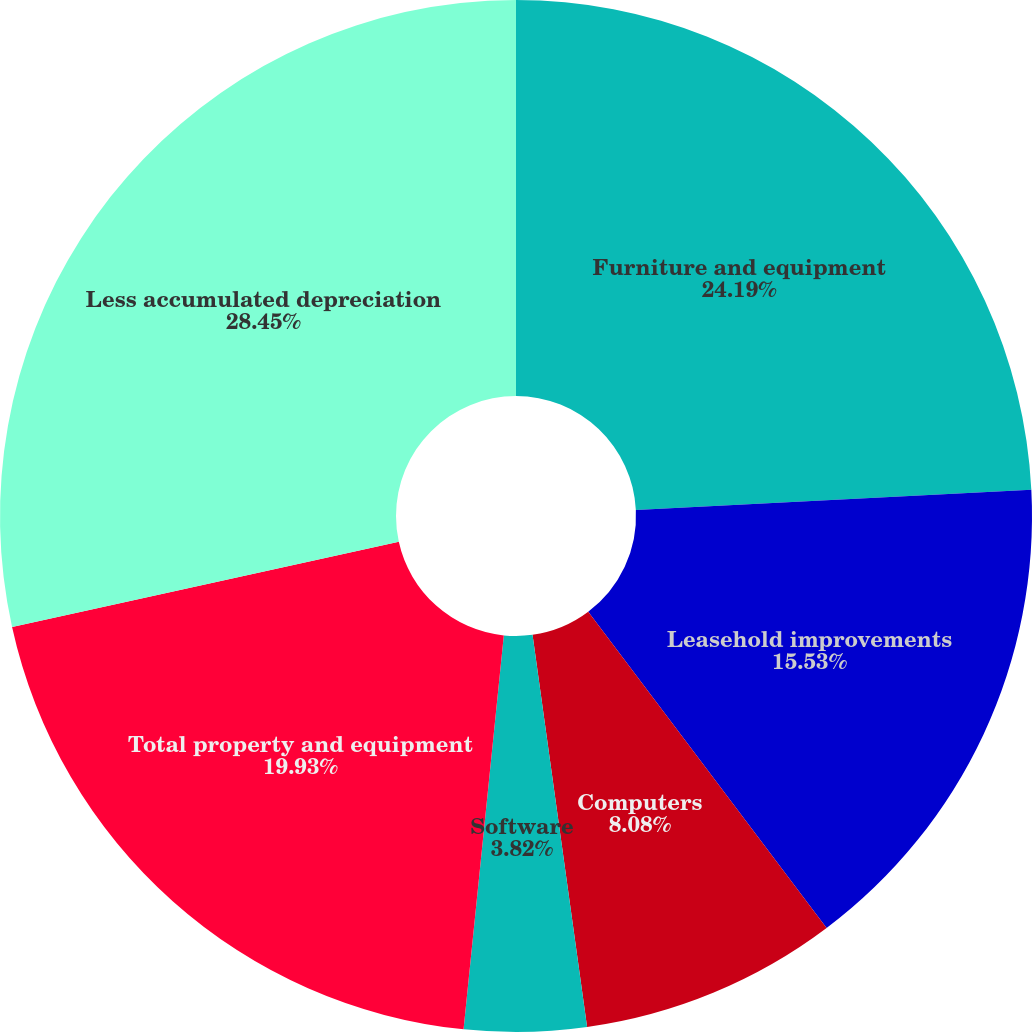Convert chart to OTSL. <chart><loc_0><loc_0><loc_500><loc_500><pie_chart><fcel>Furniture and equipment<fcel>Leasehold improvements<fcel>Computers<fcel>Software<fcel>Total property and equipment<fcel>Less accumulated depreciation<nl><fcel>24.19%<fcel>15.53%<fcel>8.08%<fcel>3.82%<fcel>19.93%<fcel>28.45%<nl></chart> 